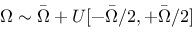<formula> <loc_0><loc_0><loc_500><loc_500>\Omega \sim \bar { \Omega } + U [ - \bar { \Omega } / 2 , + \bar { \Omega } / 2 ]</formula> 